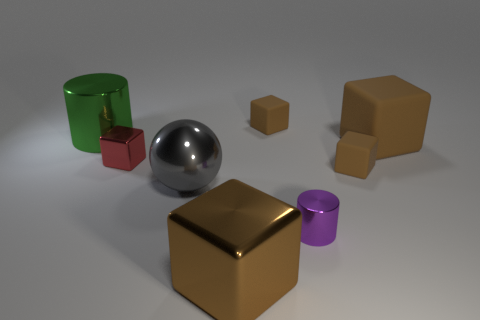How many brown cubes must be subtracted to get 2 brown cubes? 2 Subtract all tiny brown matte blocks. How many blocks are left? 3 Subtract all cyan cylinders. How many brown cubes are left? 4 Subtract 2 blocks. How many blocks are left? 3 Add 2 rubber cubes. How many objects exist? 10 Subtract all red blocks. How many blocks are left? 4 Subtract all balls. How many objects are left? 7 Subtract all blue blocks. Subtract all blue balls. How many blocks are left? 5 Subtract 0 gray cylinders. How many objects are left? 8 Subtract all red rubber cylinders. Subtract all gray things. How many objects are left? 7 